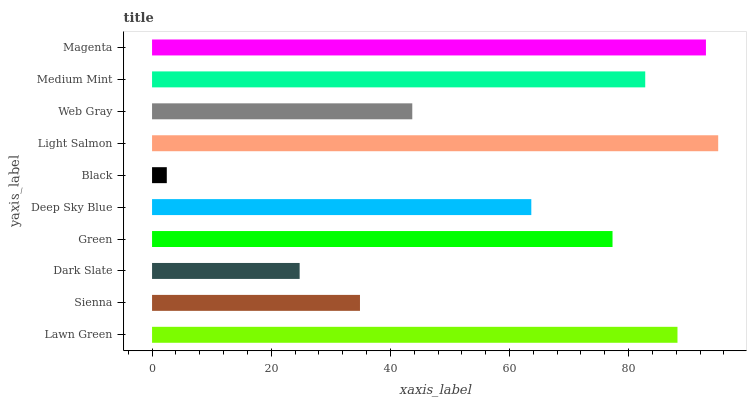Is Black the minimum?
Answer yes or no. Yes. Is Light Salmon the maximum?
Answer yes or no. Yes. Is Sienna the minimum?
Answer yes or no. No. Is Sienna the maximum?
Answer yes or no. No. Is Lawn Green greater than Sienna?
Answer yes or no. Yes. Is Sienna less than Lawn Green?
Answer yes or no. Yes. Is Sienna greater than Lawn Green?
Answer yes or no. No. Is Lawn Green less than Sienna?
Answer yes or no. No. Is Green the high median?
Answer yes or no. Yes. Is Deep Sky Blue the low median?
Answer yes or no. Yes. Is Deep Sky Blue the high median?
Answer yes or no. No. Is Green the low median?
Answer yes or no. No. 